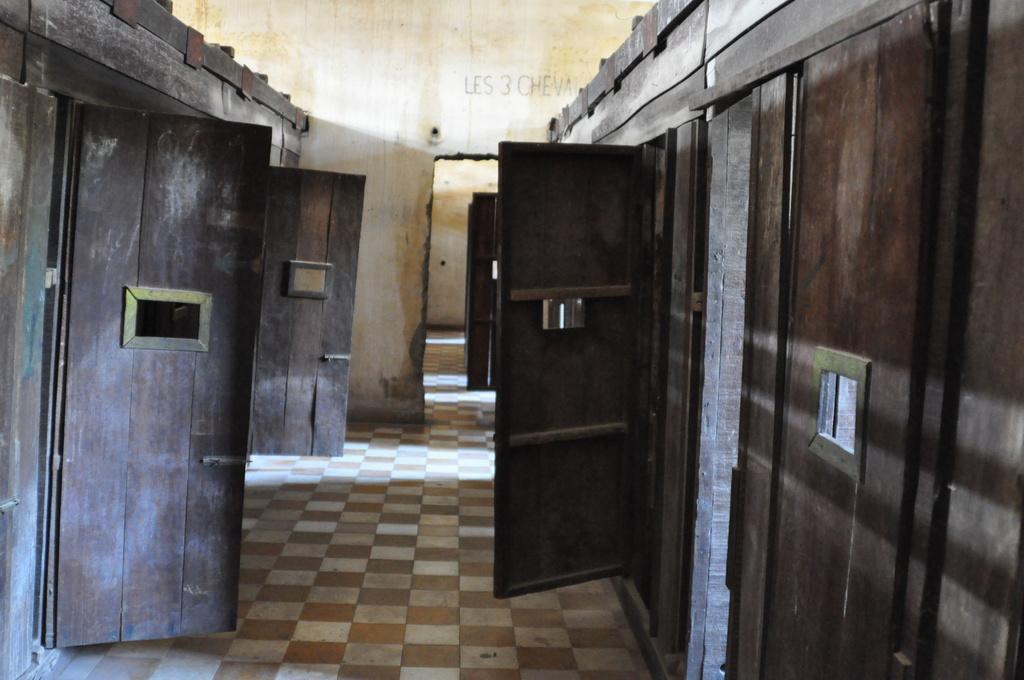What type of location is depicted in the image? The image shows the interior of a building. What can be seen underfoot in the image? There is a floor visible in the image. What color are the doors in the image? The doors in the image are brown colored. How would you describe the color of the wall in the image? The wall in the image is cream and yellow in color. Can you see any toes sticking out from under the door in the image? There are no toes visible in the image, nor is there any indication of someone's foot being under the door. 